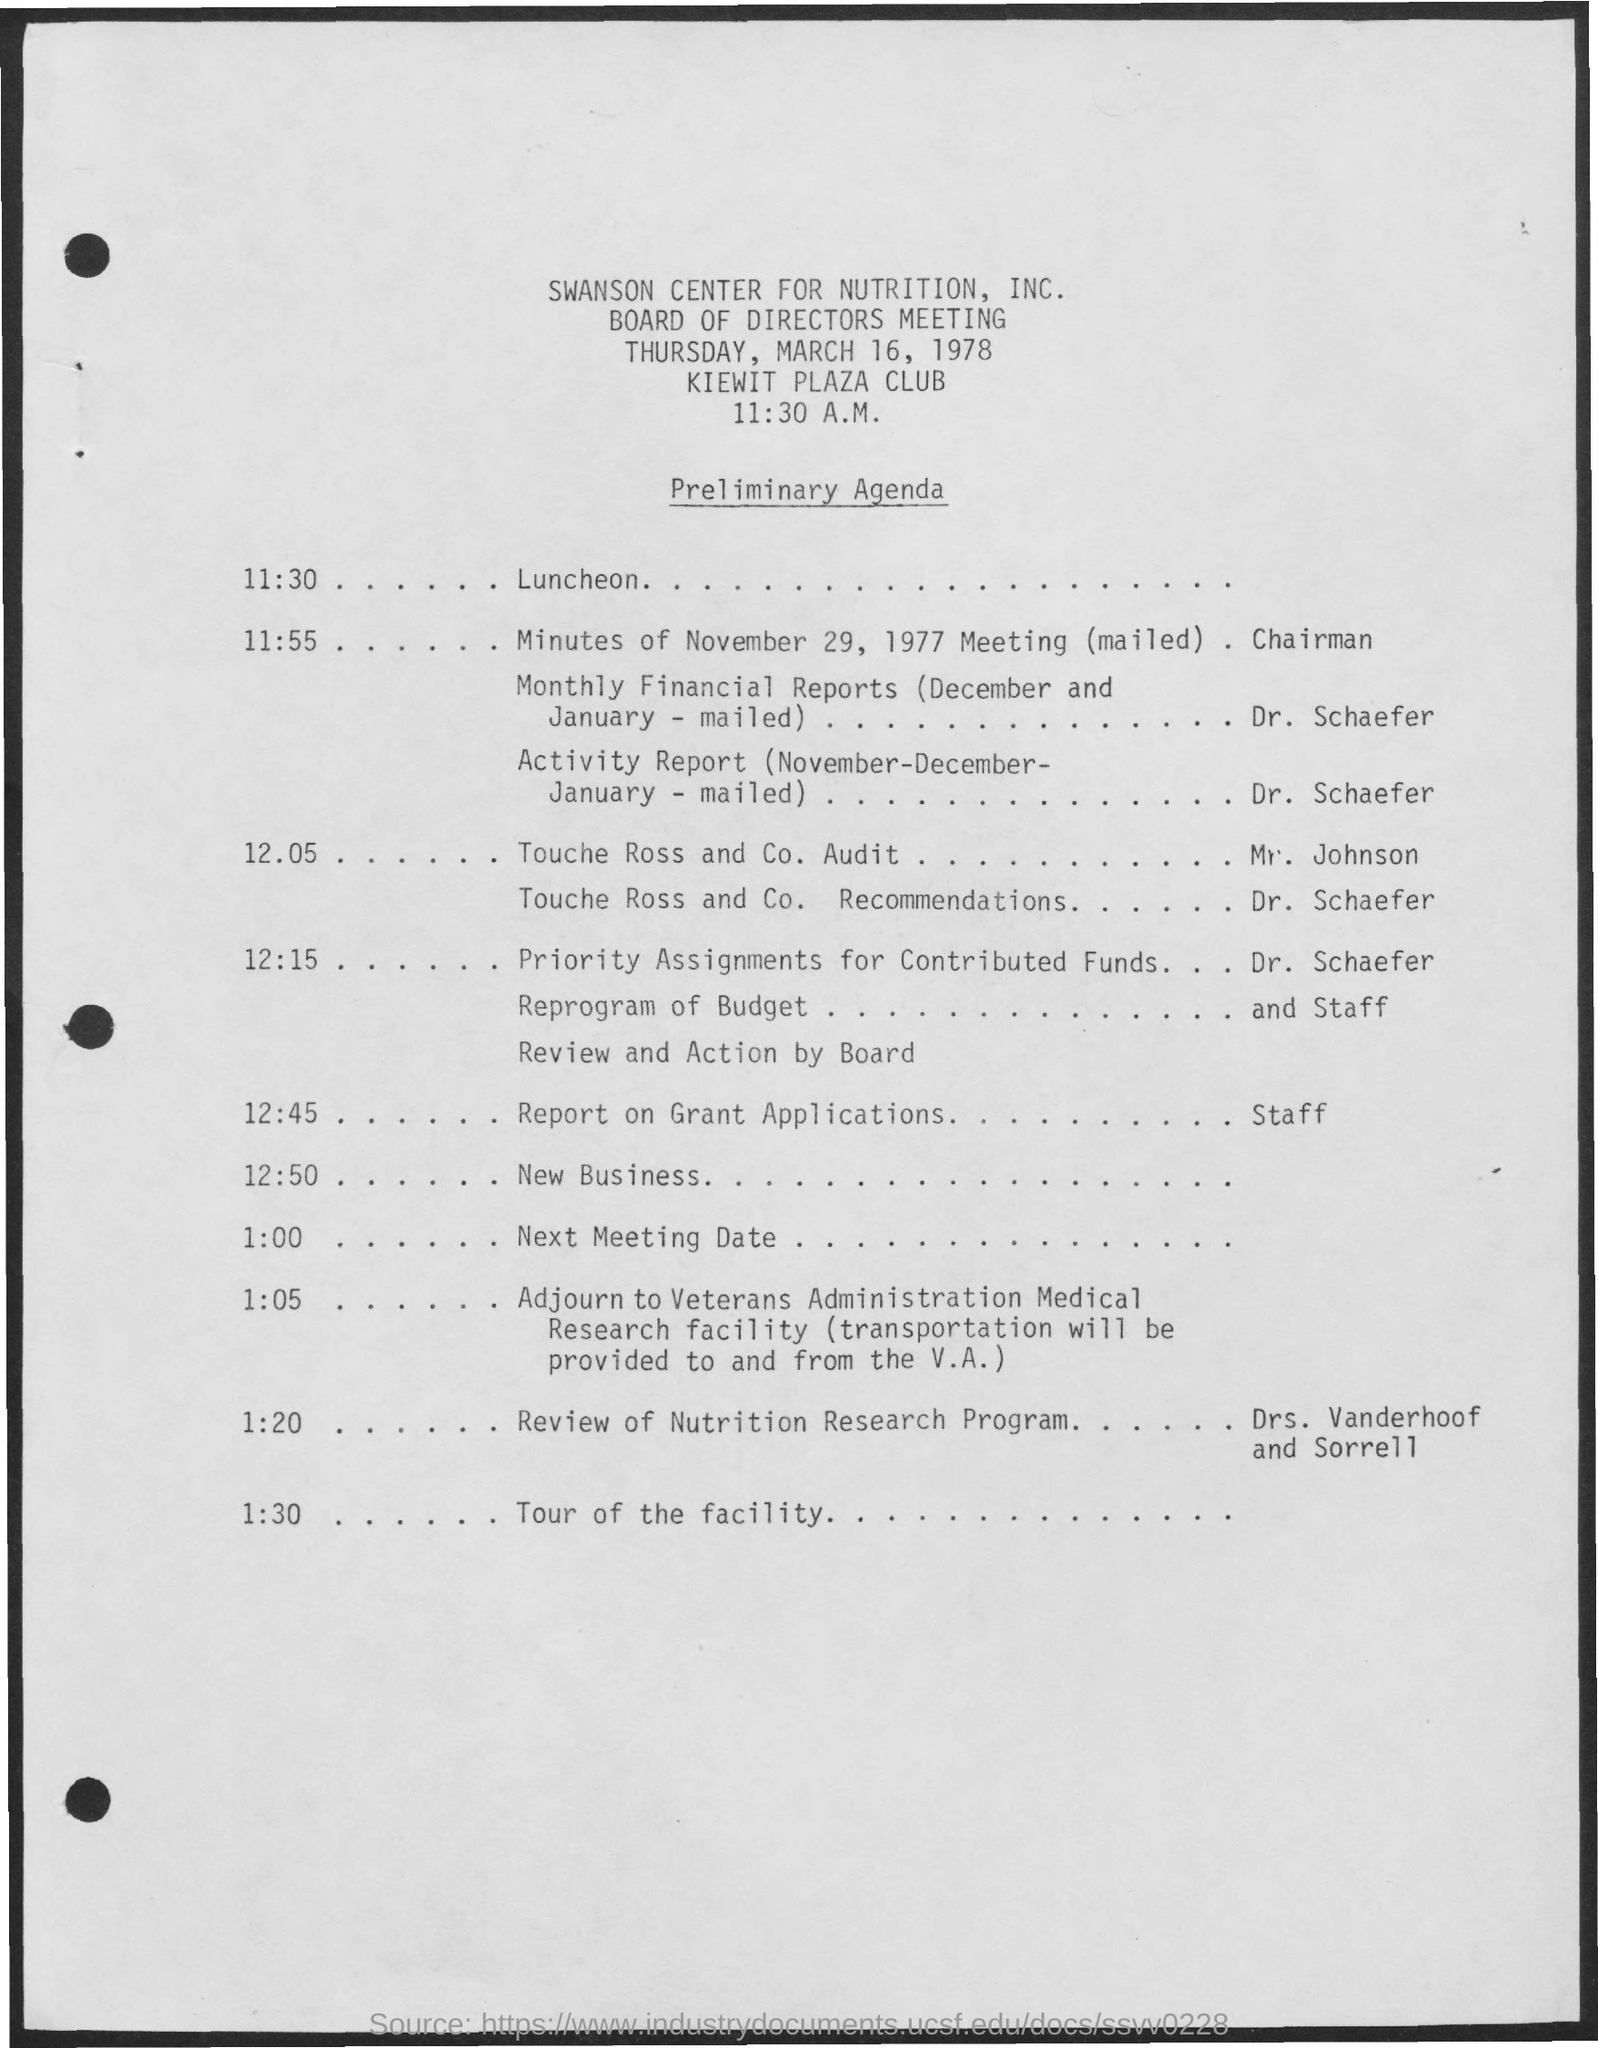What is the time mentioned in the document?
Your response must be concise. 11:30 A.M. When was the board of directors meeting?
Provide a succinct answer. March 16, 1978. 